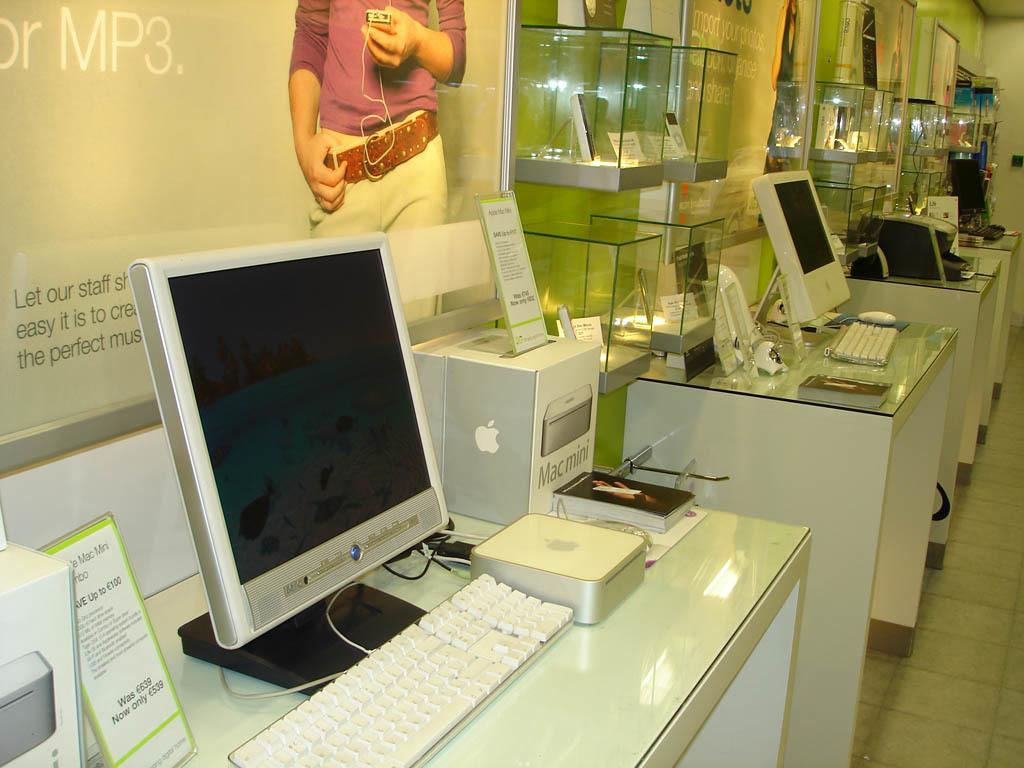<image>
Write a terse but informative summary of the picture. The computer sign behind the computer is labeled MP3 